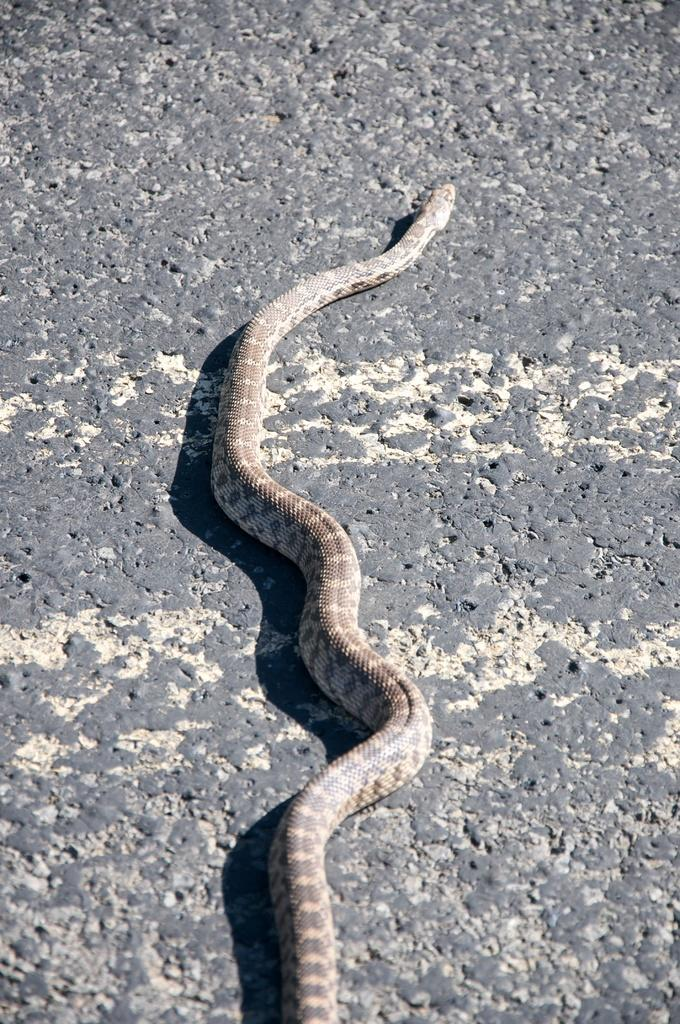What animal is present in the image? There is a snake in the image. Where is the snake located? The snake is on the ground. What type of rainstorm is depicted in the image? There is no rainstorm present in the image; it features a snake on the ground. What is the snake using to create a flame in the image? There is no flame present in the image, and snakes do not have the ability to create fire. 